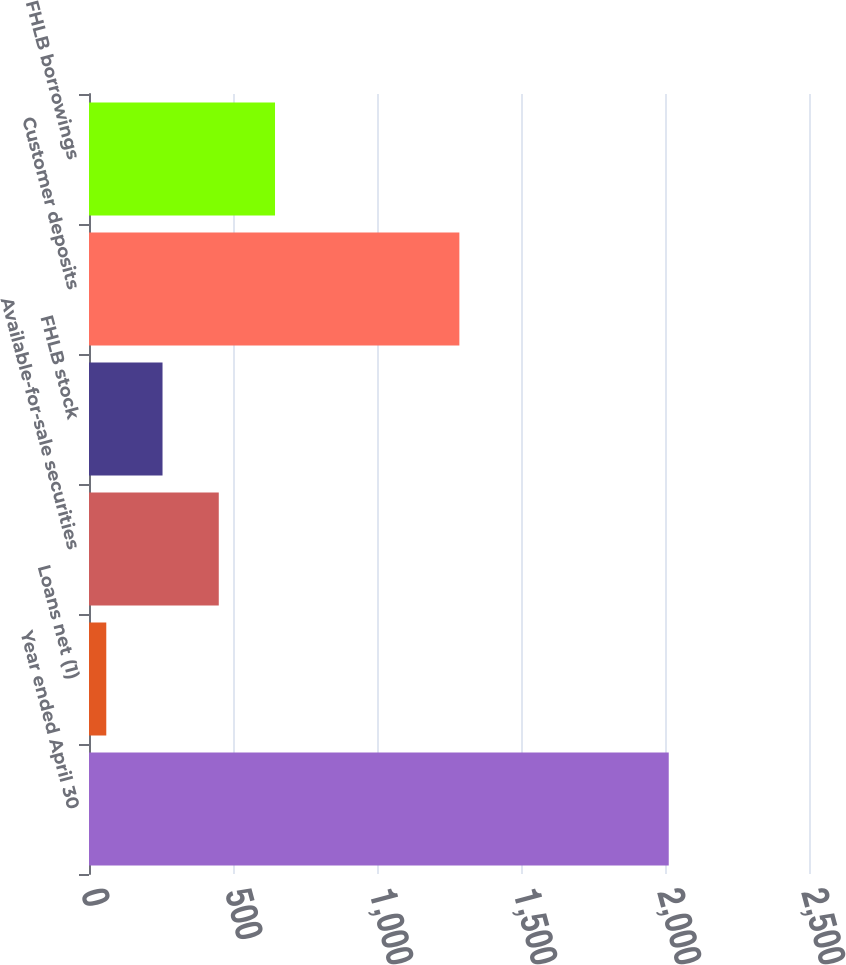Convert chart to OTSL. <chart><loc_0><loc_0><loc_500><loc_500><bar_chart><fcel>Year ended April 30<fcel>Loans net (1)<fcel>Available-for-sale securities<fcel>FHLB stock<fcel>Customer deposits<fcel>FHLB borrowings<nl><fcel>2013<fcel>60<fcel>450.6<fcel>255.3<fcel>1286<fcel>645.9<nl></chart> 